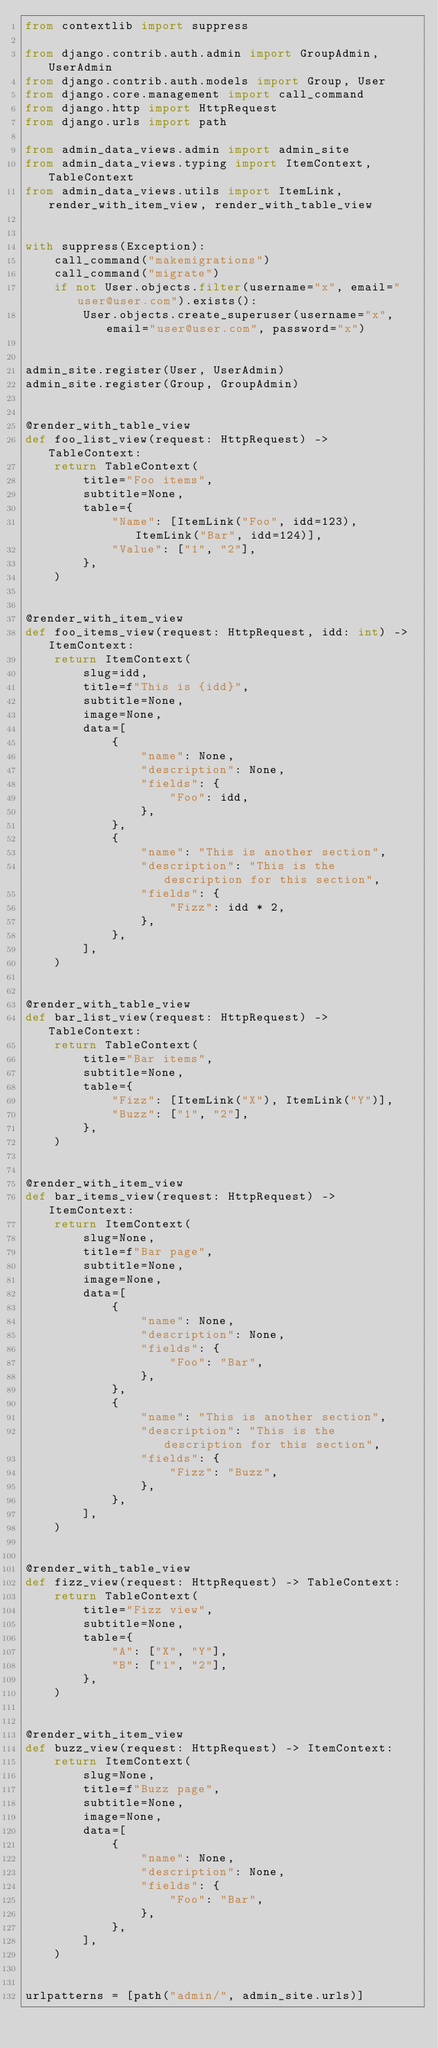Convert code to text. <code><loc_0><loc_0><loc_500><loc_500><_Python_>from contextlib import suppress

from django.contrib.auth.admin import GroupAdmin, UserAdmin
from django.contrib.auth.models import Group, User
from django.core.management import call_command
from django.http import HttpRequest
from django.urls import path

from admin_data_views.admin import admin_site
from admin_data_views.typing import ItemContext, TableContext
from admin_data_views.utils import ItemLink, render_with_item_view, render_with_table_view


with suppress(Exception):
    call_command("makemigrations")
    call_command("migrate")
    if not User.objects.filter(username="x", email="user@user.com").exists():
        User.objects.create_superuser(username="x", email="user@user.com", password="x")


admin_site.register(User, UserAdmin)
admin_site.register(Group, GroupAdmin)


@render_with_table_view
def foo_list_view(request: HttpRequest) -> TableContext:
    return TableContext(
        title="Foo items",
        subtitle=None,
        table={
            "Name": [ItemLink("Foo", idd=123), ItemLink("Bar", idd=124)],
            "Value": ["1", "2"],
        },
    )


@render_with_item_view
def foo_items_view(request: HttpRequest, idd: int) -> ItemContext:
    return ItemContext(
        slug=idd,
        title=f"This is {idd}",
        subtitle=None,
        image=None,
        data=[
            {
                "name": None,
                "description": None,
                "fields": {
                    "Foo": idd,
                },
            },
            {
                "name": "This is another section",
                "description": "This is the description for this section",
                "fields": {
                    "Fizz": idd * 2,
                },
            },
        ],
    )


@render_with_table_view
def bar_list_view(request: HttpRequest) -> TableContext:
    return TableContext(
        title="Bar items",
        subtitle=None,
        table={
            "Fizz": [ItemLink("X"), ItemLink("Y")],
            "Buzz": ["1", "2"],
        },
    )


@render_with_item_view
def bar_items_view(request: HttpRequest) -> ItemContext:
    return ItemContext(
        slug=None,
        title=f"Bar page",
        subtitle=None,
        image=None,
        data=[
            {
                "name": None,
                "description": None,
                "fields": {
                    "Foo": "Bar",
                },
            },
            {
                "name": "This is another section",
                "description": "This is the description for this section",
                "fields": {
                    "Fizz": "Buzz",
                },
            },
        ],
    )


@render_with_table_view
def fizz_view(request: HttpRequest) -> TableContext:
    return TableContext(
        title="Fizz view",
        subtitle=None,
        table={
            "A": ["X", "Y"],
            "B": ["1", "2"],
        },
    )


@render_with_item_view
def buzz_view(request: HttpRequest) -> ItemContext:
    return ItemContext(
        slug=None,
        title=f"Buzz page",
        subtitle=None,
        image=None,
        data=[
            {
                "name": None,
                "description": None,
                "fields": {
                    "Foo": "Bar",
                },
            },
        ],
    )


urlpatterns = [path("admin/", admin_site.urls)]
</code> 